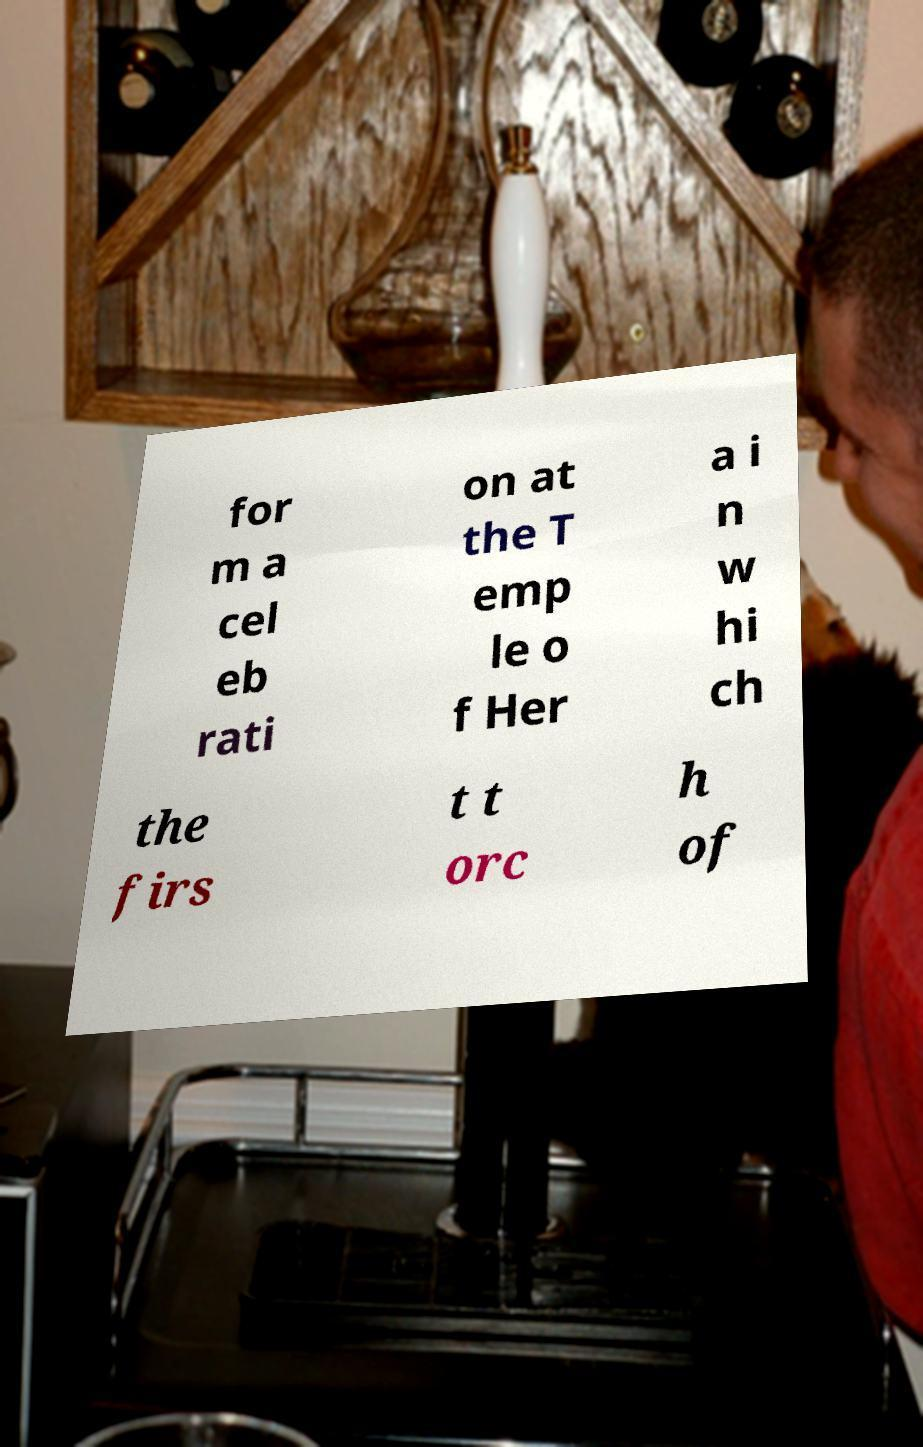I need the written content from this picture converted into text. Can you do that? for m a cel eb rati on at the T emp le o f Her a i n w hi ch the firs t t orc h of 